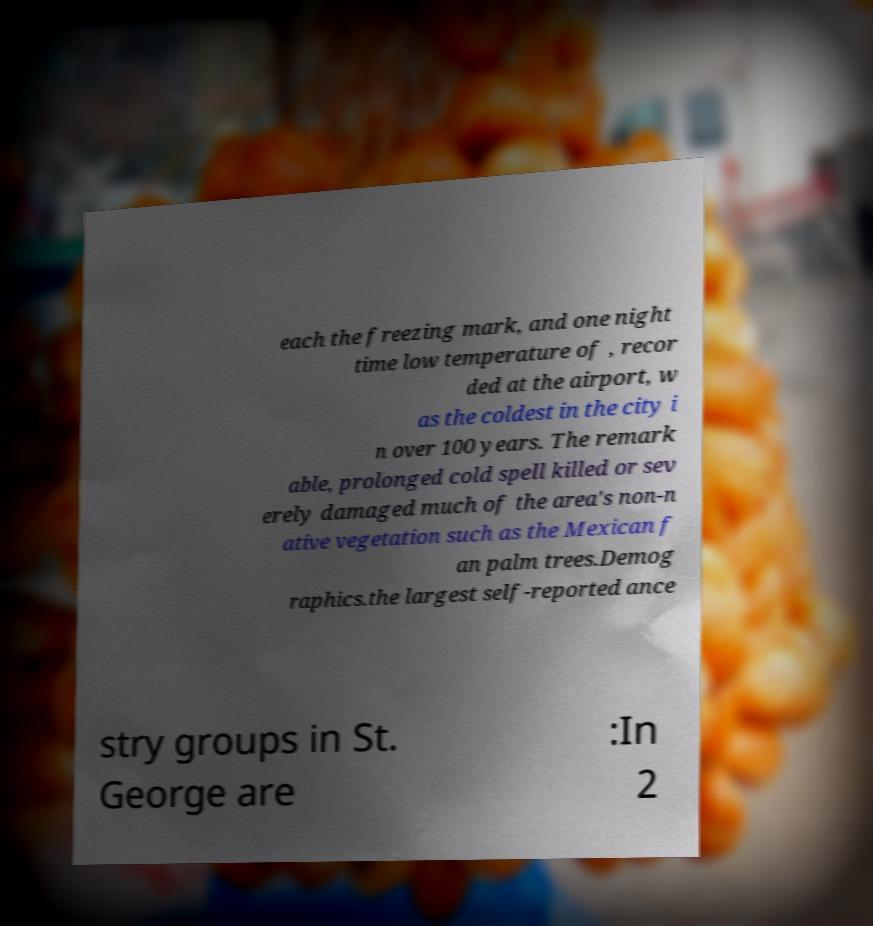There's text embedded in this image that I need extracted. Can you transcribe it verbatim? each the freezing mark, and one night time low temperature of , recor ded at the airport, w as the coldest in the city i n over 100 years. The remark able, prolonged cold spell killed or sev erely damaged much of the area's non-n ative vegetation such as the Mexican f an palm trees.Demog raphics.the largest self-reported ance stry groups in St. George are :In 2 